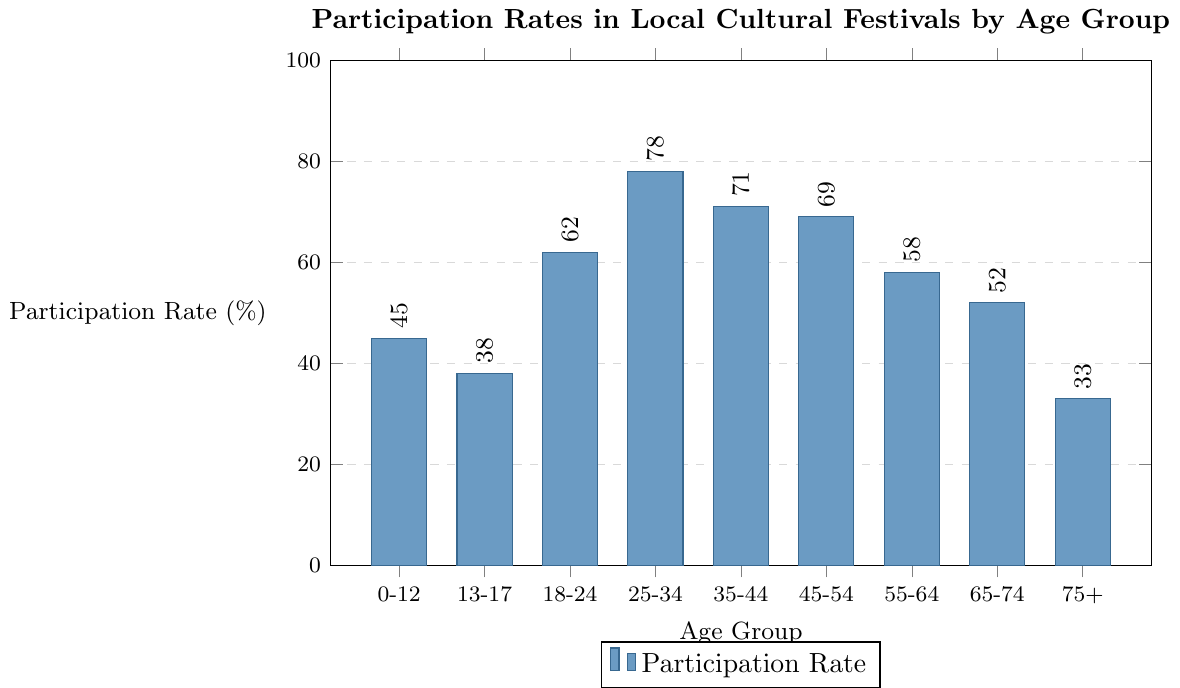What age group has the highest participation rate? By looking at the highest bar in the chart, it corresponds to the 25-34 age group, which has a participation rate of 78%.
Answer: 25-34 Which age group has the lowest participation rate? By identifying the shortest bar in the chart, it corresponds to the 75+ age group, which has a participation rate of 33%.
Answer: 75+ What is the difference in participation rates between the 25-34 and 75+ age groups? The participation rate for the 25-34 age group is 78%, and for the 75+ age group, it is 33%. The difference is calculated as 78% - 33%.
Answer: 45% Which age groups have participation rates above 60%? By looking at the bars with heights above the 60% mark, we see the age groups 18-24, 25-34, 35-44, and 45-54.
Answer: 18-24, 25-34, 35-44, 45-54 What is the median participation rate across all age groups? To find the median, the rates are arranged in ascending order: 33%, 38%, 45%, 52%, 58%, 62%, 69%, 71%, 78%. The median value (middle value) is 58%, corresponding to the 55-64 age group.
Answer: 58% By how much does the participation rate of the 35-44 age group exceed that of the 13-17 age group? The participation rate for the 35-44 age group is 71%, and for the 13-17 age group, it is 38%. The difference is calculated as 71% - 38%.
Answer: 33% What is the average participation rate of all age groups? Summing all the participation rates: 45 + 38 + 62 + 78 + 71 + 69 + 58 + 52 + 33 = 506. There are 9 age groups, so the average is 506/9.
Answer: 56.22% Which two age groups have the closest participation rates? By comparing the values, the closest rates are 69% (45-54) and 71% (35-44), with a difference of only 2%.
Answer: 35-44 and 45-54 How does the participation rate of children (0-12) compare with that of seniors (65-74)? The participation rate for the 0-12 age group is 45%, and for the 65-74 age group, it is 52%. Thus, seniors participate more compared to children by 52% - 45%.
Answer: Seniors participate 7% more 